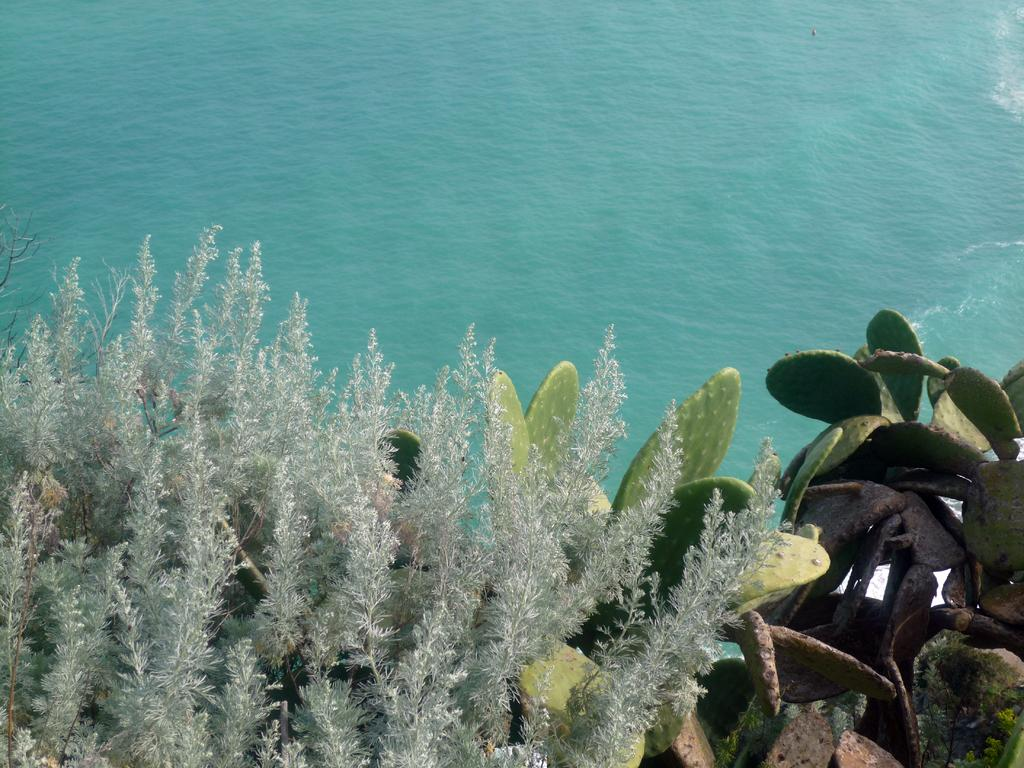What can be seen towards the top of the image? There is water visible towards the top of the image. What is present towards the bottom of the image? There are plants visible towards the bottom of the image. What type of drink does the aunt offer in the image? There is no aunt or drink present in the image. How does the trip to the beach affect the plants in the image? There is no trip to the beach or any beach-related context in the image. 